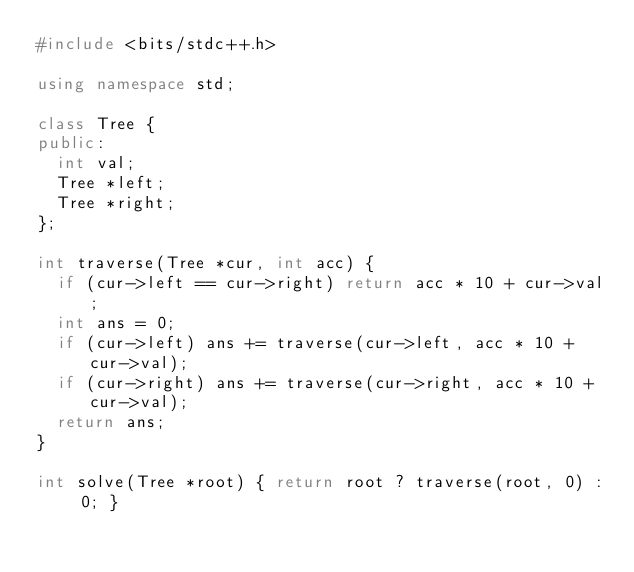<code> <loc_0><loc_0><loc_500><loc_500><_C++_>#include <bits/stdc++.h>

using namespace std;

class Tree {
public:
	int val;
	Tree *left;
	Tree *right;
};

int traverse(Tree *cur, int acc) {
	if (cur->left == cur->right) return acc * 10 + cur->val;
	int ans = 0;
	if (cur->left) ans += traverse(cur->left, acc * 10 + cur->val);
	if (cur->right) ans += traverse(cur->right, acc * 10 + cur->val);
	return ans;
}

int solve(Tree *root) { return root ? traverse(root, 0) : 0; }</code> 